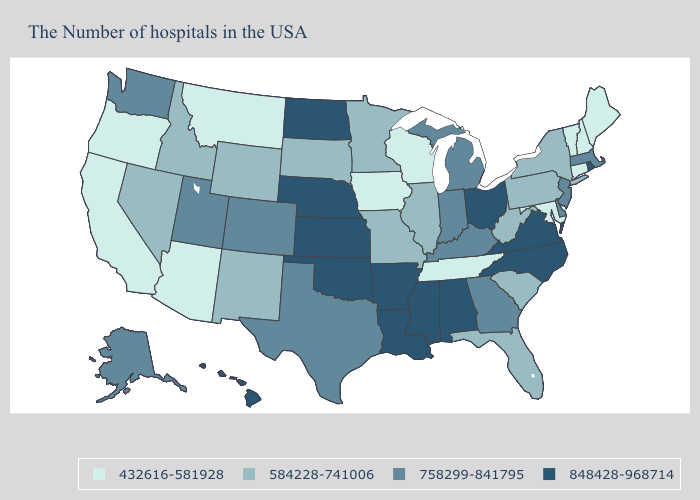What is the highest value in the USA?
Concise answer only. 848428-968714. What is the lowest value in the Northeast?
Be succinct. 432616-581928. Does the first symbol in the legend represent the smallest category?
Write a very short answer. Yes. Name the states that have a value in the range 584228-741006?
Concise answer only. New York, Pennsylvania, South Carolina, West Virginia, Florida, Illinois, Missouri, Minnesota, South Dakota, Wyoming, New Mexico, Idaho, Nevada. Which states hav the highest value in the Northeast?
Answer briefly. Rhode Island. What is the highest value in the USA?
Write a very short answer. 848428-968714. What is the value of Iowa?
Give a very brief answer. 432616-581928. How many symbols are there in the legend?
Quick response, please. 4. Does West Virginia have a higher value than Vermont?
Give a very brief answer. Yes. Which states have the lowest value in the Northeast?
Keep it brief. Maine, New Hampshire, Vermont, Connecticut. What is the lowest value in the West?
Quick response, please. 432616-581928. How many symbols are there in the legend?
Answer briefly. 4. Which states have the lowest value in the South?
Be succinct. Maryland, Tennessee. How many symbols are there in the legend?
Quick response, please. 4. Name the states that have a value in the range 758299-841795?
Write a very short answer. Massachusetts, New Jersey, Delaware, Georgia, Michigan, Kentucky, Indiana, Texas, Colorado, Utah, Washington, Alaska. 